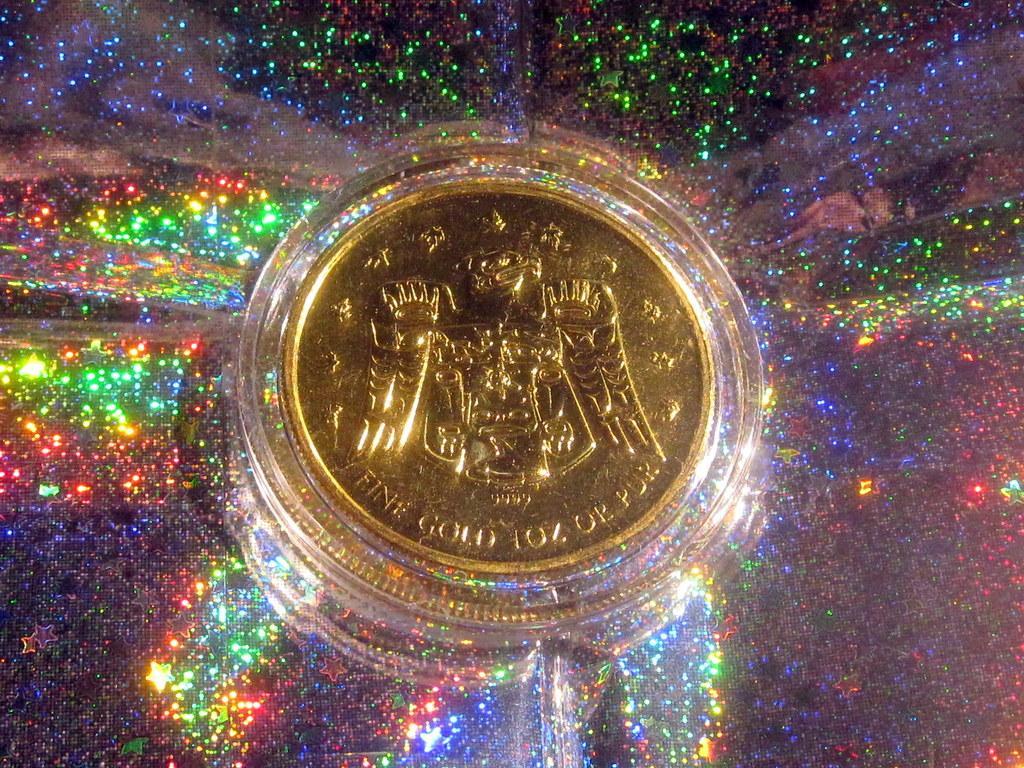In one or two sentences, can you explain what this image depicts? In this image I can see a gold coin. Back I can see few stars and the colorful background. 